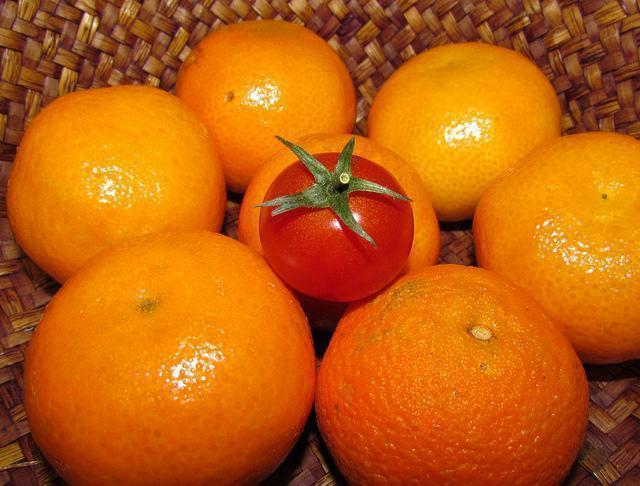What vegetable is shown in the picture?
Select the accurate response from the four choices given to answer the question.
Options: Broccoli, lettuce, tomato, spinach. Tomato. 